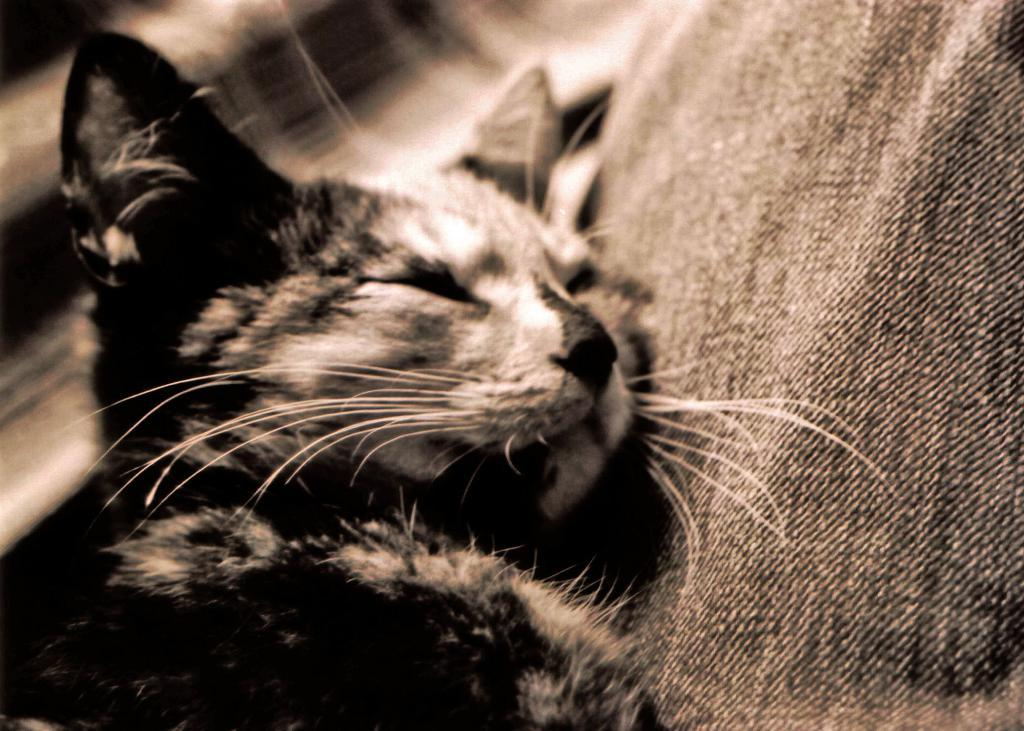What type of animal is in the image? There is a cat in the image. Can you describe the cat's coloring? The cat has black, brown, and white colors. What can be observed about the background of the image? The background of the image is blurred. How does the zephyr affect the cat's fur in the image? There is no mention of a zephyr or any wind in the image, so its effect on the cat's fur cannot be determined. 